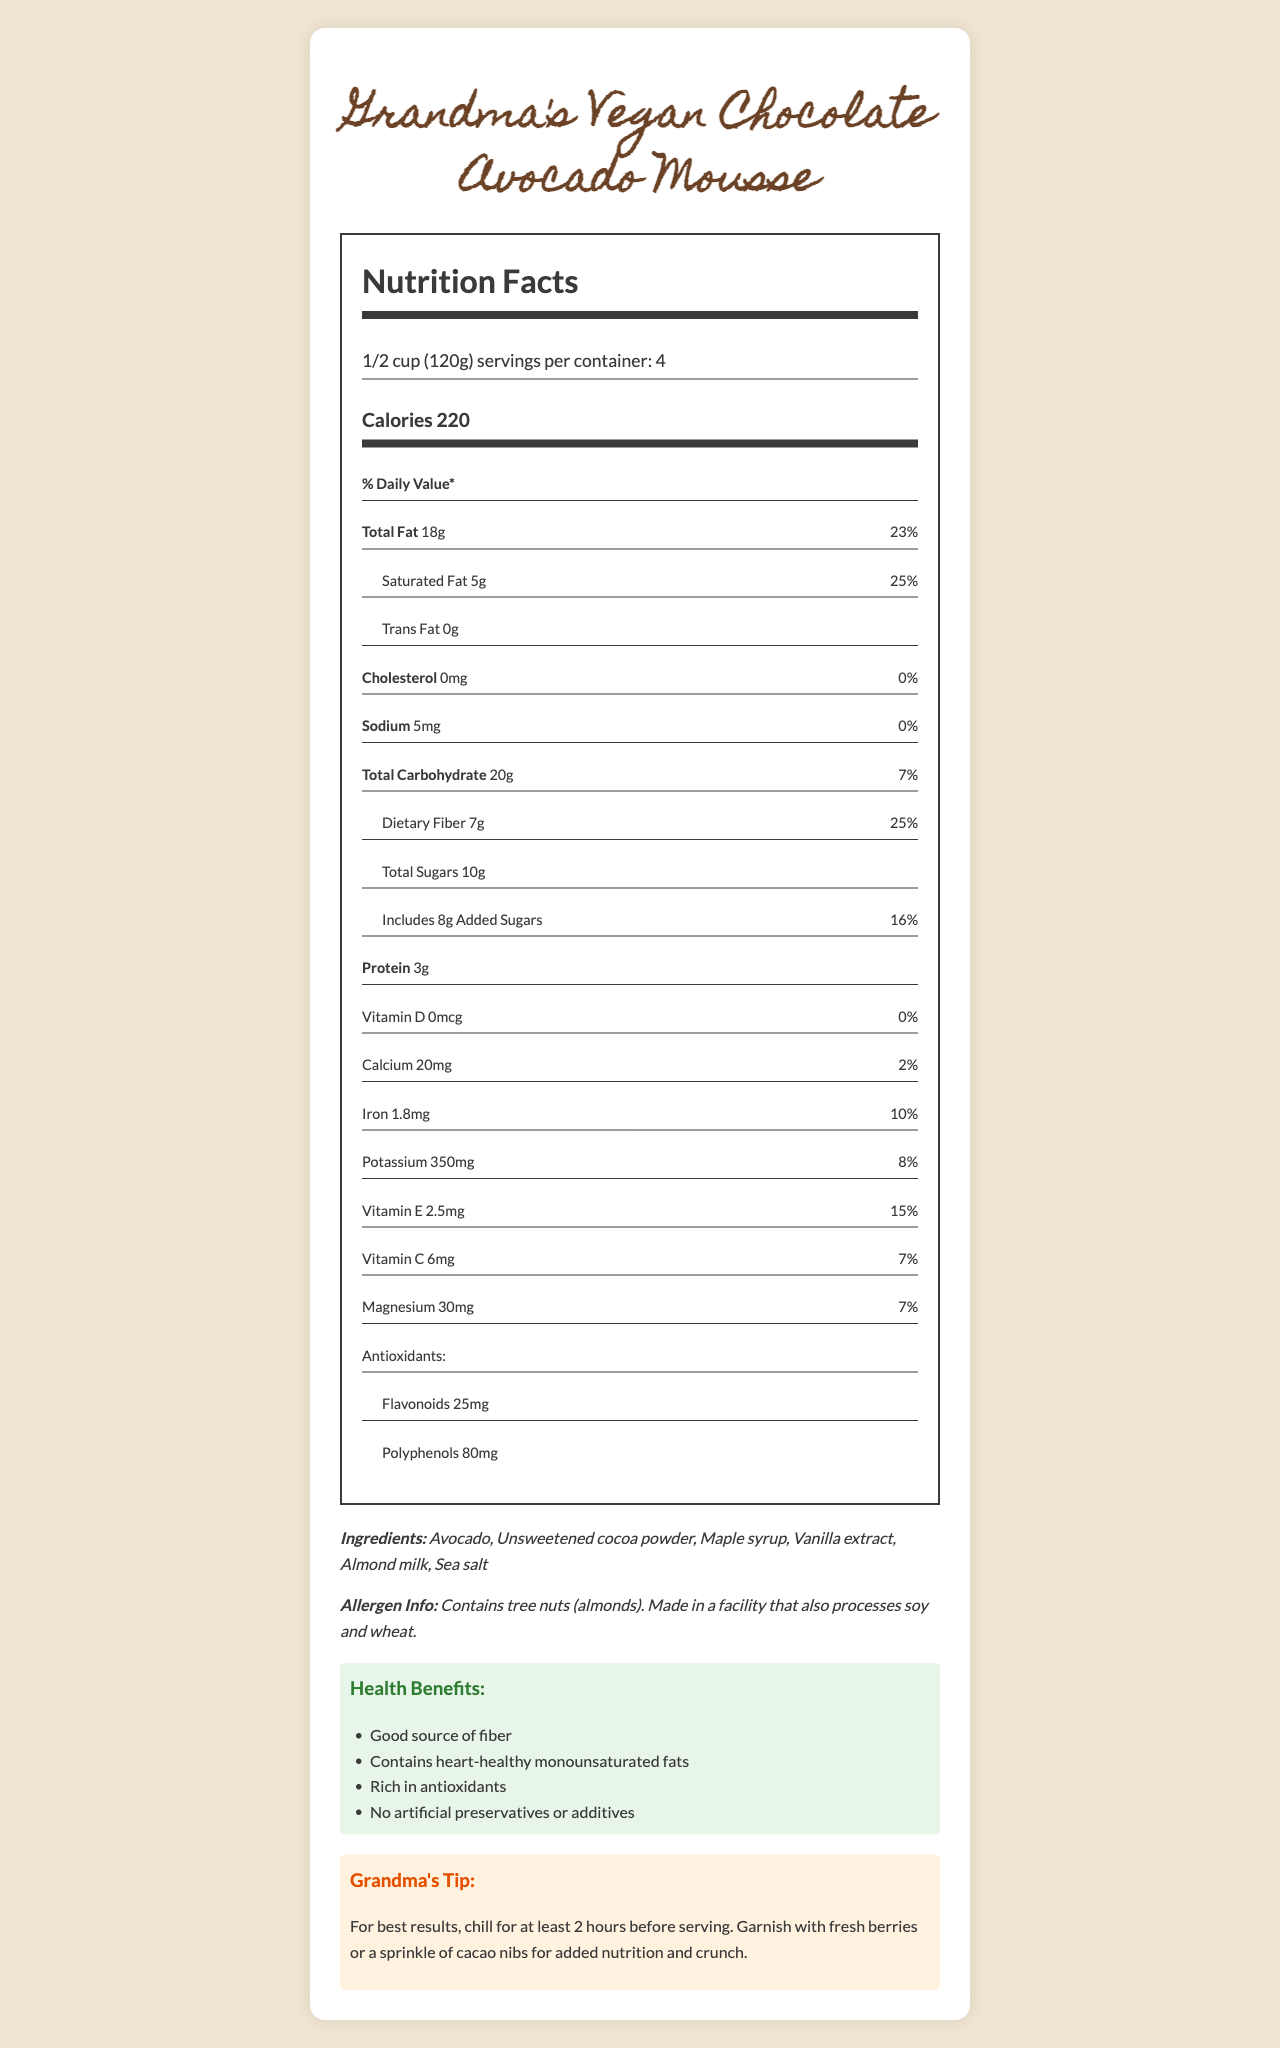what is the serving size? The serving size is listed at the top of the nutrition label as "1/2 cup (120g)".
Answer: 1/2 cup (120g) how many servings are in one container? The document states "servings per container: 4" under the serving size section.
Answer: 4 what is the total fat content per serving? The total fat content per serving is shown as "Total Fat 18g".
Answer: 18g how much dietary fiber is there in each serving? The dietary fiber content is labeled as "Dietary Fiber 7g".
Answer: 7g what are the main ingredients of this mousse? The ingredients are listed near the bottom of the document.
Answer: Avocado, Unsweetened cocoa powder, Maple syrup, Vanilla extract, Almond milk, Sea salt how many calories are in one serving of the mousse? The calorie content per serving is listed as "Calories 220".
Answer: 220 Is this mousse a good source of antioxidants? (Yes/No) The document highlights that it is "Rich in antioxidants" and lists flavonoids and polyphenols under antioxidants.
Answer: Yes what percentage of daily value does the saturated fat content provide? The daily value percentage for saturated fat is listed as "25%".
Answer: 25% how much sugar is added to each serving? The amount of added sugars is listed as "8g" under "Includes 8g Added Sugars".
Answer: 8g which vitamin has the highest daily value percentage in this mousse? Vitamin E has a daily value percentage of 15%, which is higher compared to other vitamins listed.
Answer: Vitamin E - 15% how much iron is there in one serving? The iron content in one serving is shown as "Iron 1.8mg".
Answer: 1.8mg what allergens are present in this mousse? The allergen information section states "Contains tree nuts (almonds)".
Answer: Tree nuts (almonds) what is the amount of sodium per serving? Sodium content per serving is listed as "Sodium 5mg".
Answer: 5mg how much potassium is in each serving? A. 150mg B. 250mg C. 350mg D. 450mg The potassium content per serving is "Potassium 350mg".
Answer: C. 350mg which of the following is NOT listed as an ingredient? A. Avocado B. Almond milk C. Coconut sugar D. Sea salt The listed ingredients are Avocado, Unsweetened cocoa powder, Maple syrup, Vanilla extract, Almond milk, and Sea salt.
Answer: C. Coconut sugar does this mousse contain cholesterol? The cholesterol content is listed as "0mg" and the daily value percentage is also "0%".
Answer: No how would you summarize the document? The document is a comprehensive nutritional label for a vegan chocolate avocado mousse, emphasizing its healthy fats and antioxidant content, along with detailing its ingredients and preparation tips.
Answer: The document provides detailed nutritional information for "Grandma's Vegan Chocolate Avocado Mousse," including serving size, calories, fats, carbohydrates, proteins, and vitamins. It lists ingredients, allergen information, health claims, and preparation tips. how long should you chill the mousse before serving for best results? The preparation tips suggest chilling the mousse for at least 2 hours before serving for optimal results.
Answer: At least 2 hours what is the daily value percentage of calcium in this mousse? The daily value percentage for calcium is listed as "2%" in the document.
Answer: 2% what's the total carbohydrate content per serving? The total carbohydrate content per serving is listed as "Total Carbohydrate 20g".
Answer: 20g how many grams of protein does each serving contain? A. 1g B. 2g C. 3g D. 4g The protein content per serving is listed as "Protein 3g".
Answer: C. 3g what's the main idea of the health claims section? The health claims section lists the nutritional benefits of the mousse such as being a good source of fiber, containing healthy fats and antioxidants, and having no artificial additives.
Answer: The mousse is promoted as being high in fiber, containing heart-healthy monounsaturated fats, rich in antioxidants, and free from artificial preservatives or additives. 